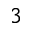Convert formula to latex. <formula><loc_0><loc_0><loc_500><loc_500>3</formula> 